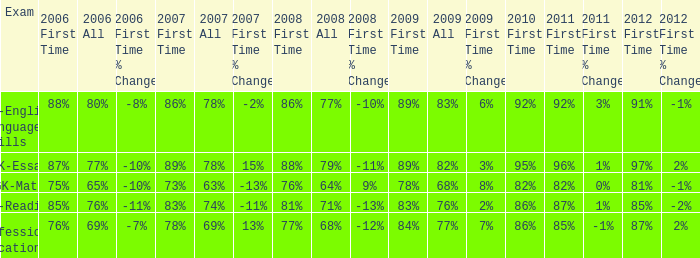What is the percentage for first time 2011 when the first time in 2009 is 68%? 82%. 